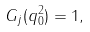<formula> <loc_0><loc_0><loc_500><loc_500>G _ { j } ( q _ { 0 } ^ { 2 } ) = 1 ,</formula> 